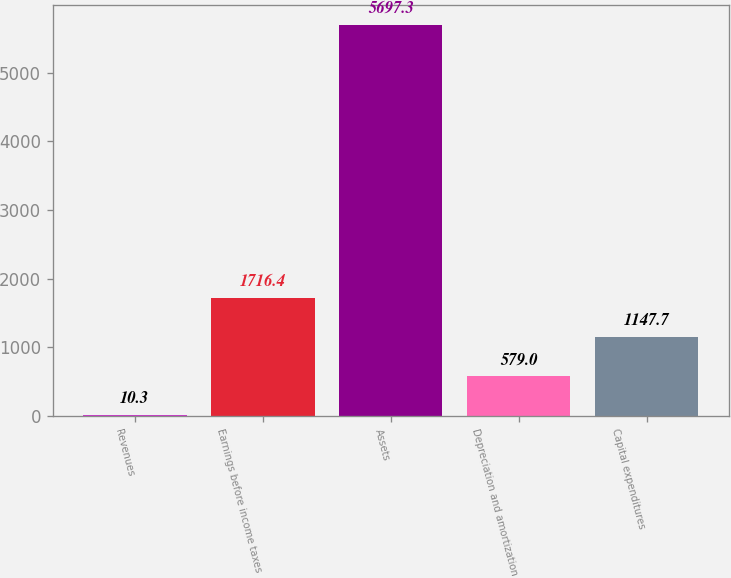Convert chart to OTSL. <chart><loc_0><loc_0><loc_500><loc_500><bar_chart><fcel>Revenues<fcel>Earnings before income taxes<fcel>Assets<fcel>Depreciation and amortization<fcel>Capital expenditures<nl><fcel>10.3<fcel>1716.4<fcel>5697.3<fcel>579<fcel>1147.7<nl></chart> 